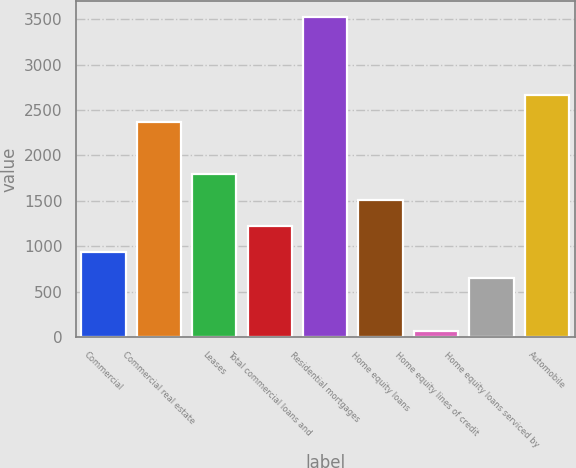Convert chart. <chart><loc_0><loc_0><loc_500><loc_500><bar_chart><fcel>Commercial<fcel>Commercial real estate<fcel>Leases<fcel>Total commercial loans and<fcel>Residential mortgages<fcel>Home equity loans<fcel>Home equity lines of credit<fcel>Home equity loans serviced by<fcel>Automobile<nl><fcel>933.4<fcel>2372.4<fcel>1796.8<fcel>1221.2<fcel>3523.6<fcel>1509<fcel>70<fcel>645.6<fcel>2660.2<nl></chart> 